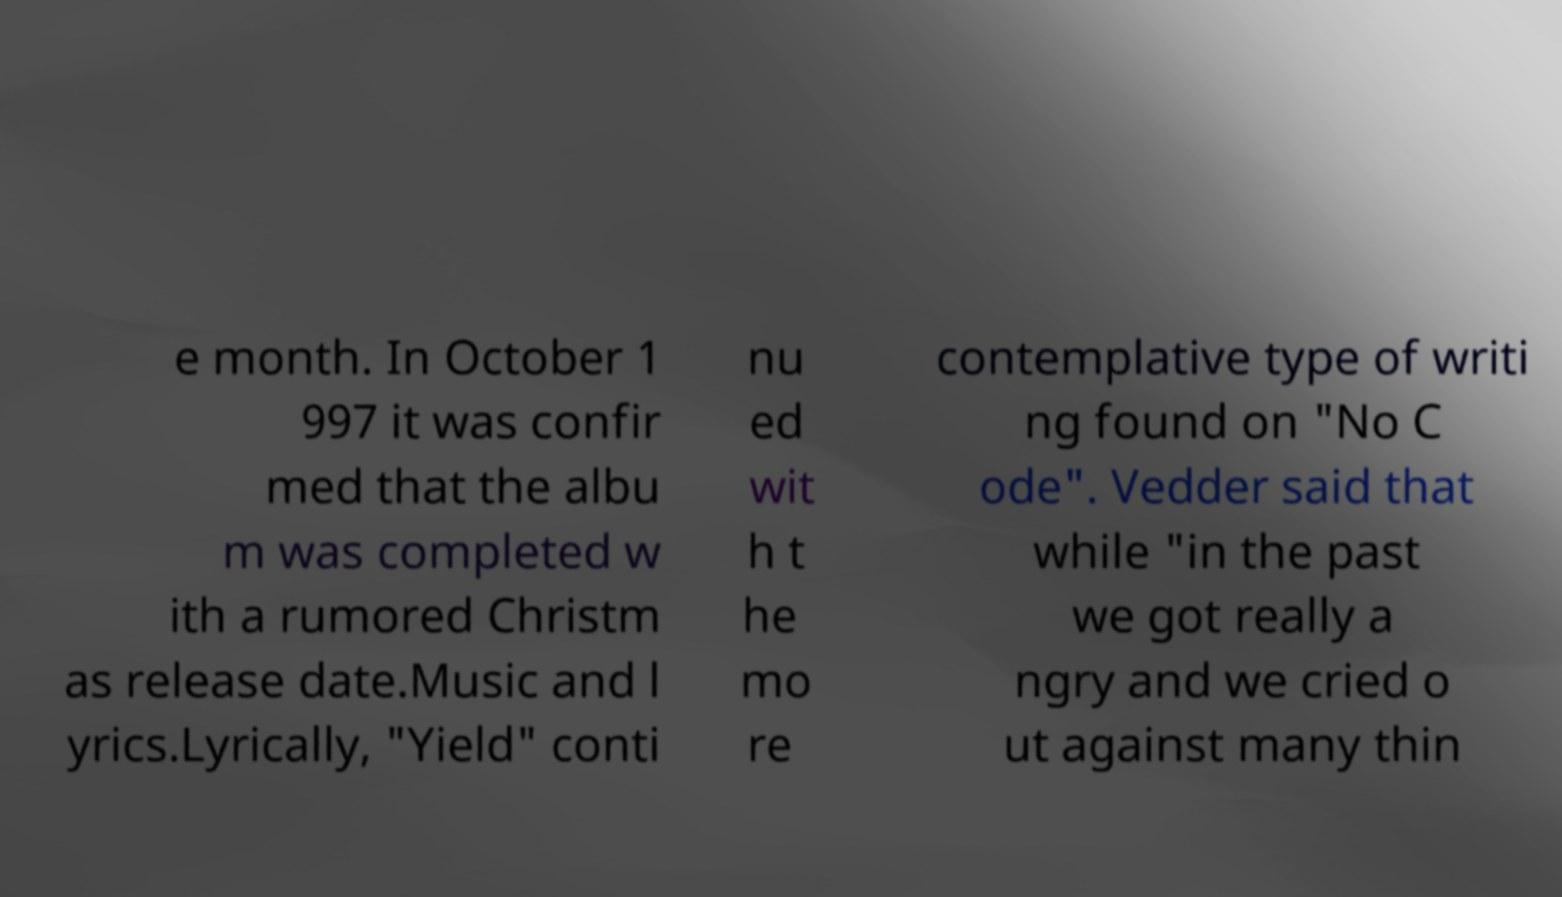Please read and relay the text visible in this image. What does it say? e month. In October 1 997 it was confir med that the albu m was completed w ith a rumored Christm as release date.Music and l yrics.Lyrically, "Yield" conti nu ed wit h t he mo re contemplative type of writi ng found on "No C ode". Vedder said that while "in the past we got really a ngry and we cried o ut against many thin 